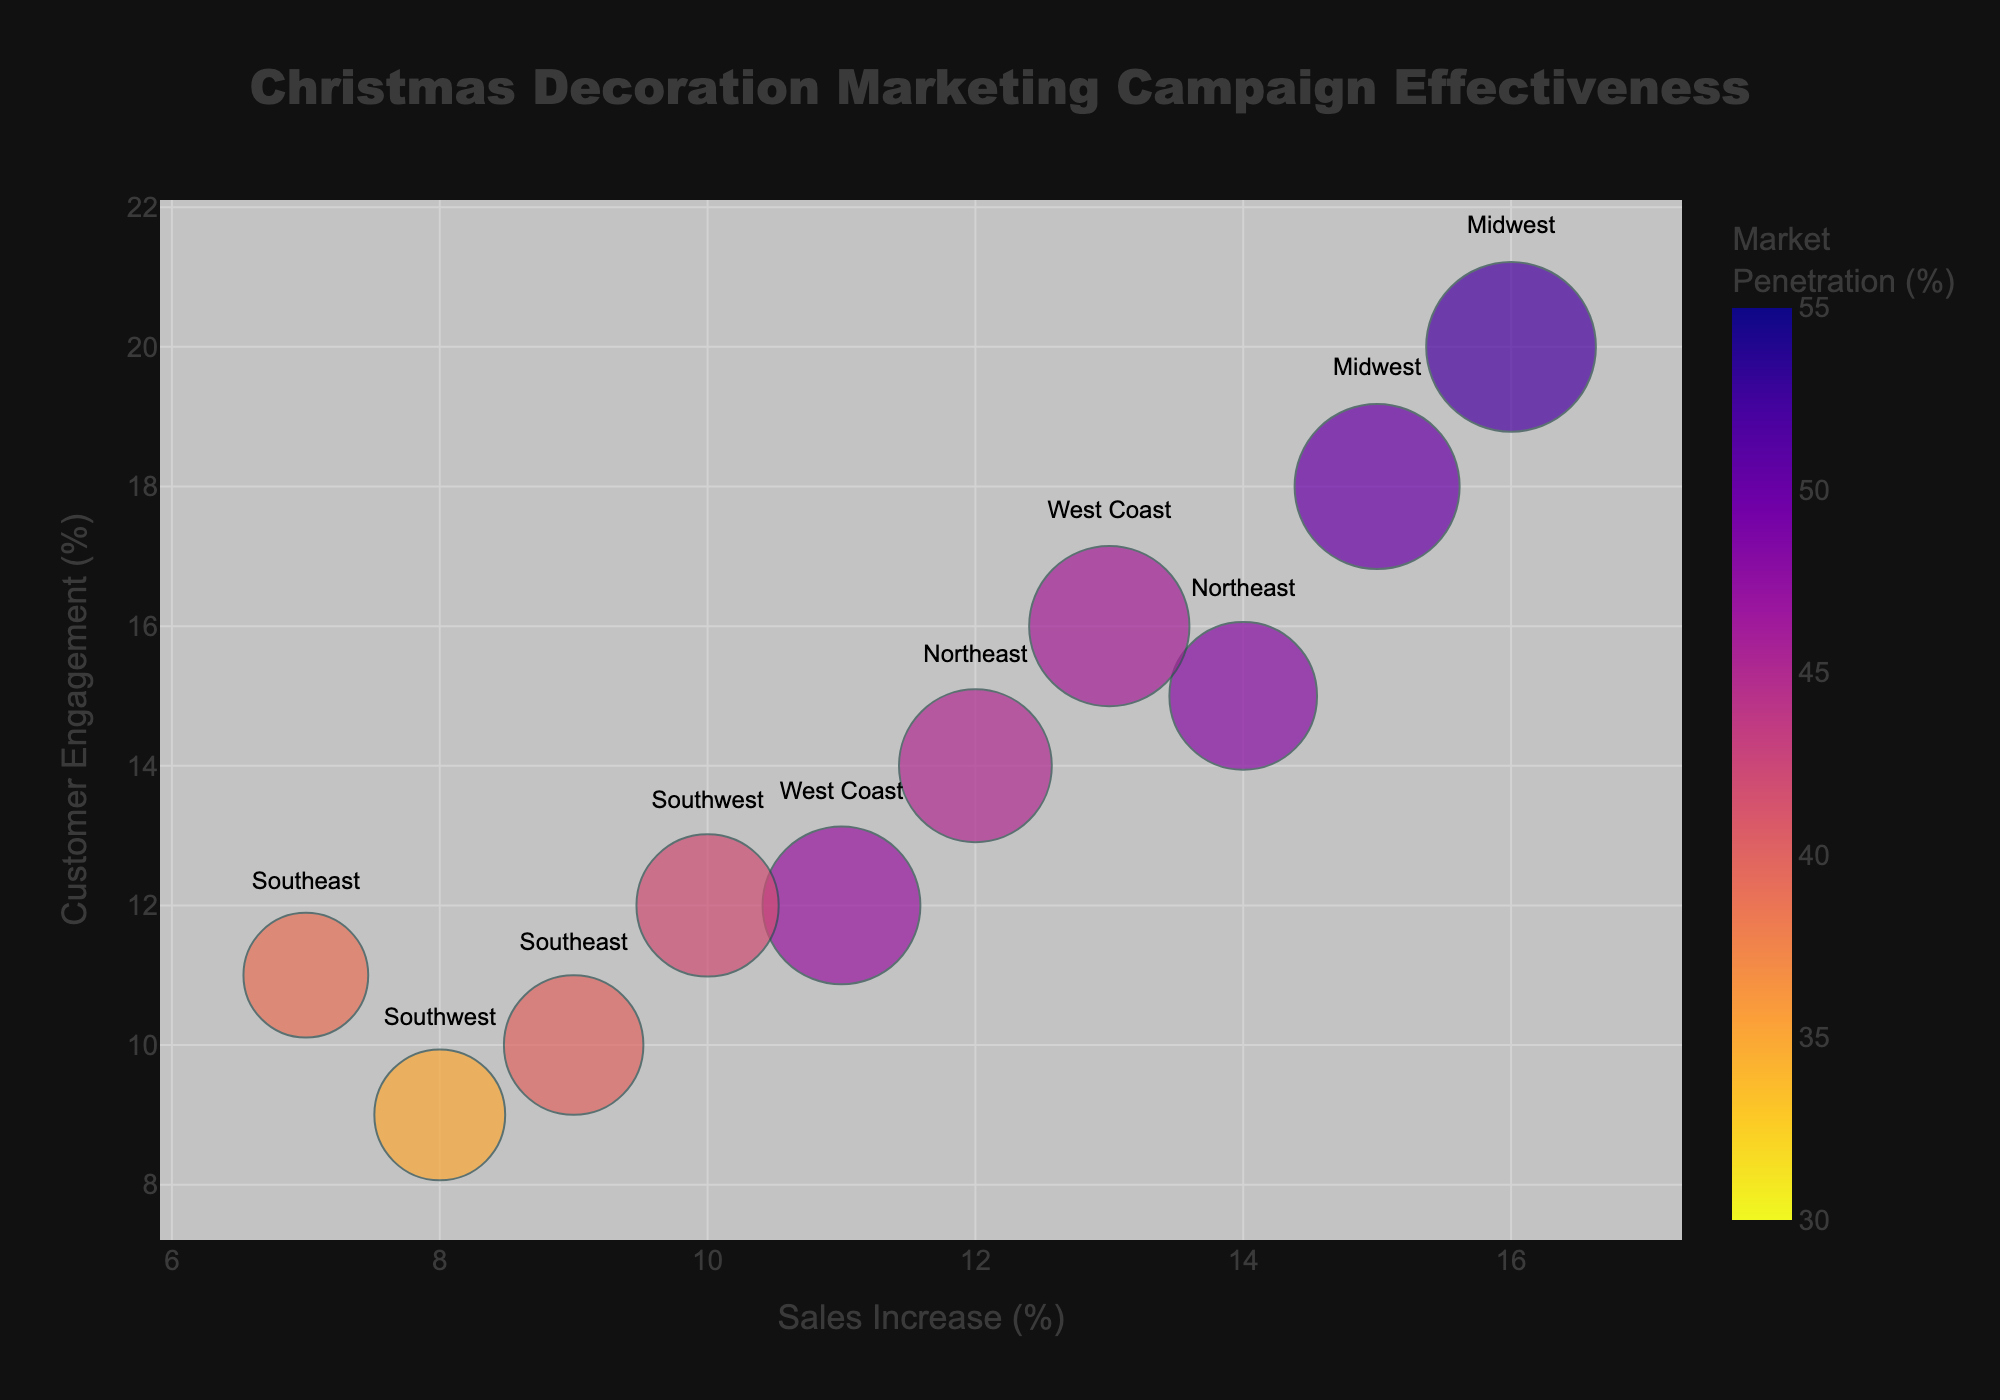What is the title of the plot? The title of the plot is located at the top and is centered. It reads "Christmas Decoration Marketing Campaign Effectiveness".
Answer: Christmas Decoration Marketing Campaign Effectiveness How many data points (bubbles) are displayed in the plot? By counting each bubble in the plot, we can determine that there are 10 total data points.
Answer: 10 Which campaign shows the highest sales increase percentage? By finding the bubble positioned farthest to the right on the x-axis, we see that "Santa's Workshop" in the Midwest has the highest sales increase at 16%.
Answer: Santa's Workshop Which region is associated with the "Festive Wonderland" campaign? The label next to the bubble for "Festive Wonderland" reads "West Coast".
Answer: West Coast What is the market penetration percentage associated with the "Christmas Spectacular" campaign? The color gradient and the color bar on the right indicate the color intensity related to market penetration. "Christmas Spectacular" shows a color that corresponds to 42% market penetration.
Answer: 42% How does customer engagement (%) correlate with sales increase (%) for the "Winter Wonderland" and "Jingle Jamboree" campaigns in the Northeast? Both campaigns have similar customer engagement values (Winter Wonderland: 14%, Jingle Jamboree: 15%). Compare these values with their corresponding sales increase (Winter Wonderland: 12%, Jingle Jamboree: 14%). Jingle Jamboree has a slightly higher sales increase and customer engagement compared to Winter Wonderland.
Answer: Jingle Jamboree has slightly higher values Which campaign has the highest ad spend, and how does its sales increase compare to others? The size of the bubbles indicates ad spend. The largest bubble corresponds to "Santa's Workshop" with an ad spend of $37,000. It also has the highest sales increase at 16%.
Answer: Santa's Workshop; highest sales increase at 16% Compare the customer engagement (%) of the campaigns on the West Coast. Which one is higher? The West Coast region has two campaigns: "Joyful Celebrations" with 12% and "Festive Wonderland" with 16%. "Festive Wonderland" has a higher customer engagement.
Answer: Festive Wonderland What is the average sales increase (%) for campaigns in the Midwest region? The campaigns are "Snowy Bliss" (15%) and "Santa's Workshop" (16%). The average is calculated as (15 + 16) / 2 = 15.5%.
Answer: 15.5% Which campaign bubble shows a moderate size, indicating average ad spend, and what are its sales increase and customer engagement percentages? By observing the sizes of the bubbles, "Christmas Spectacular" seems moderately sized, indicating an average ad spend of $26,000. It has a sales increase of 10% and customer engagement of 12%.
Answer: Christmas Spectacular; 10% sales increase, 12% customer engagement 